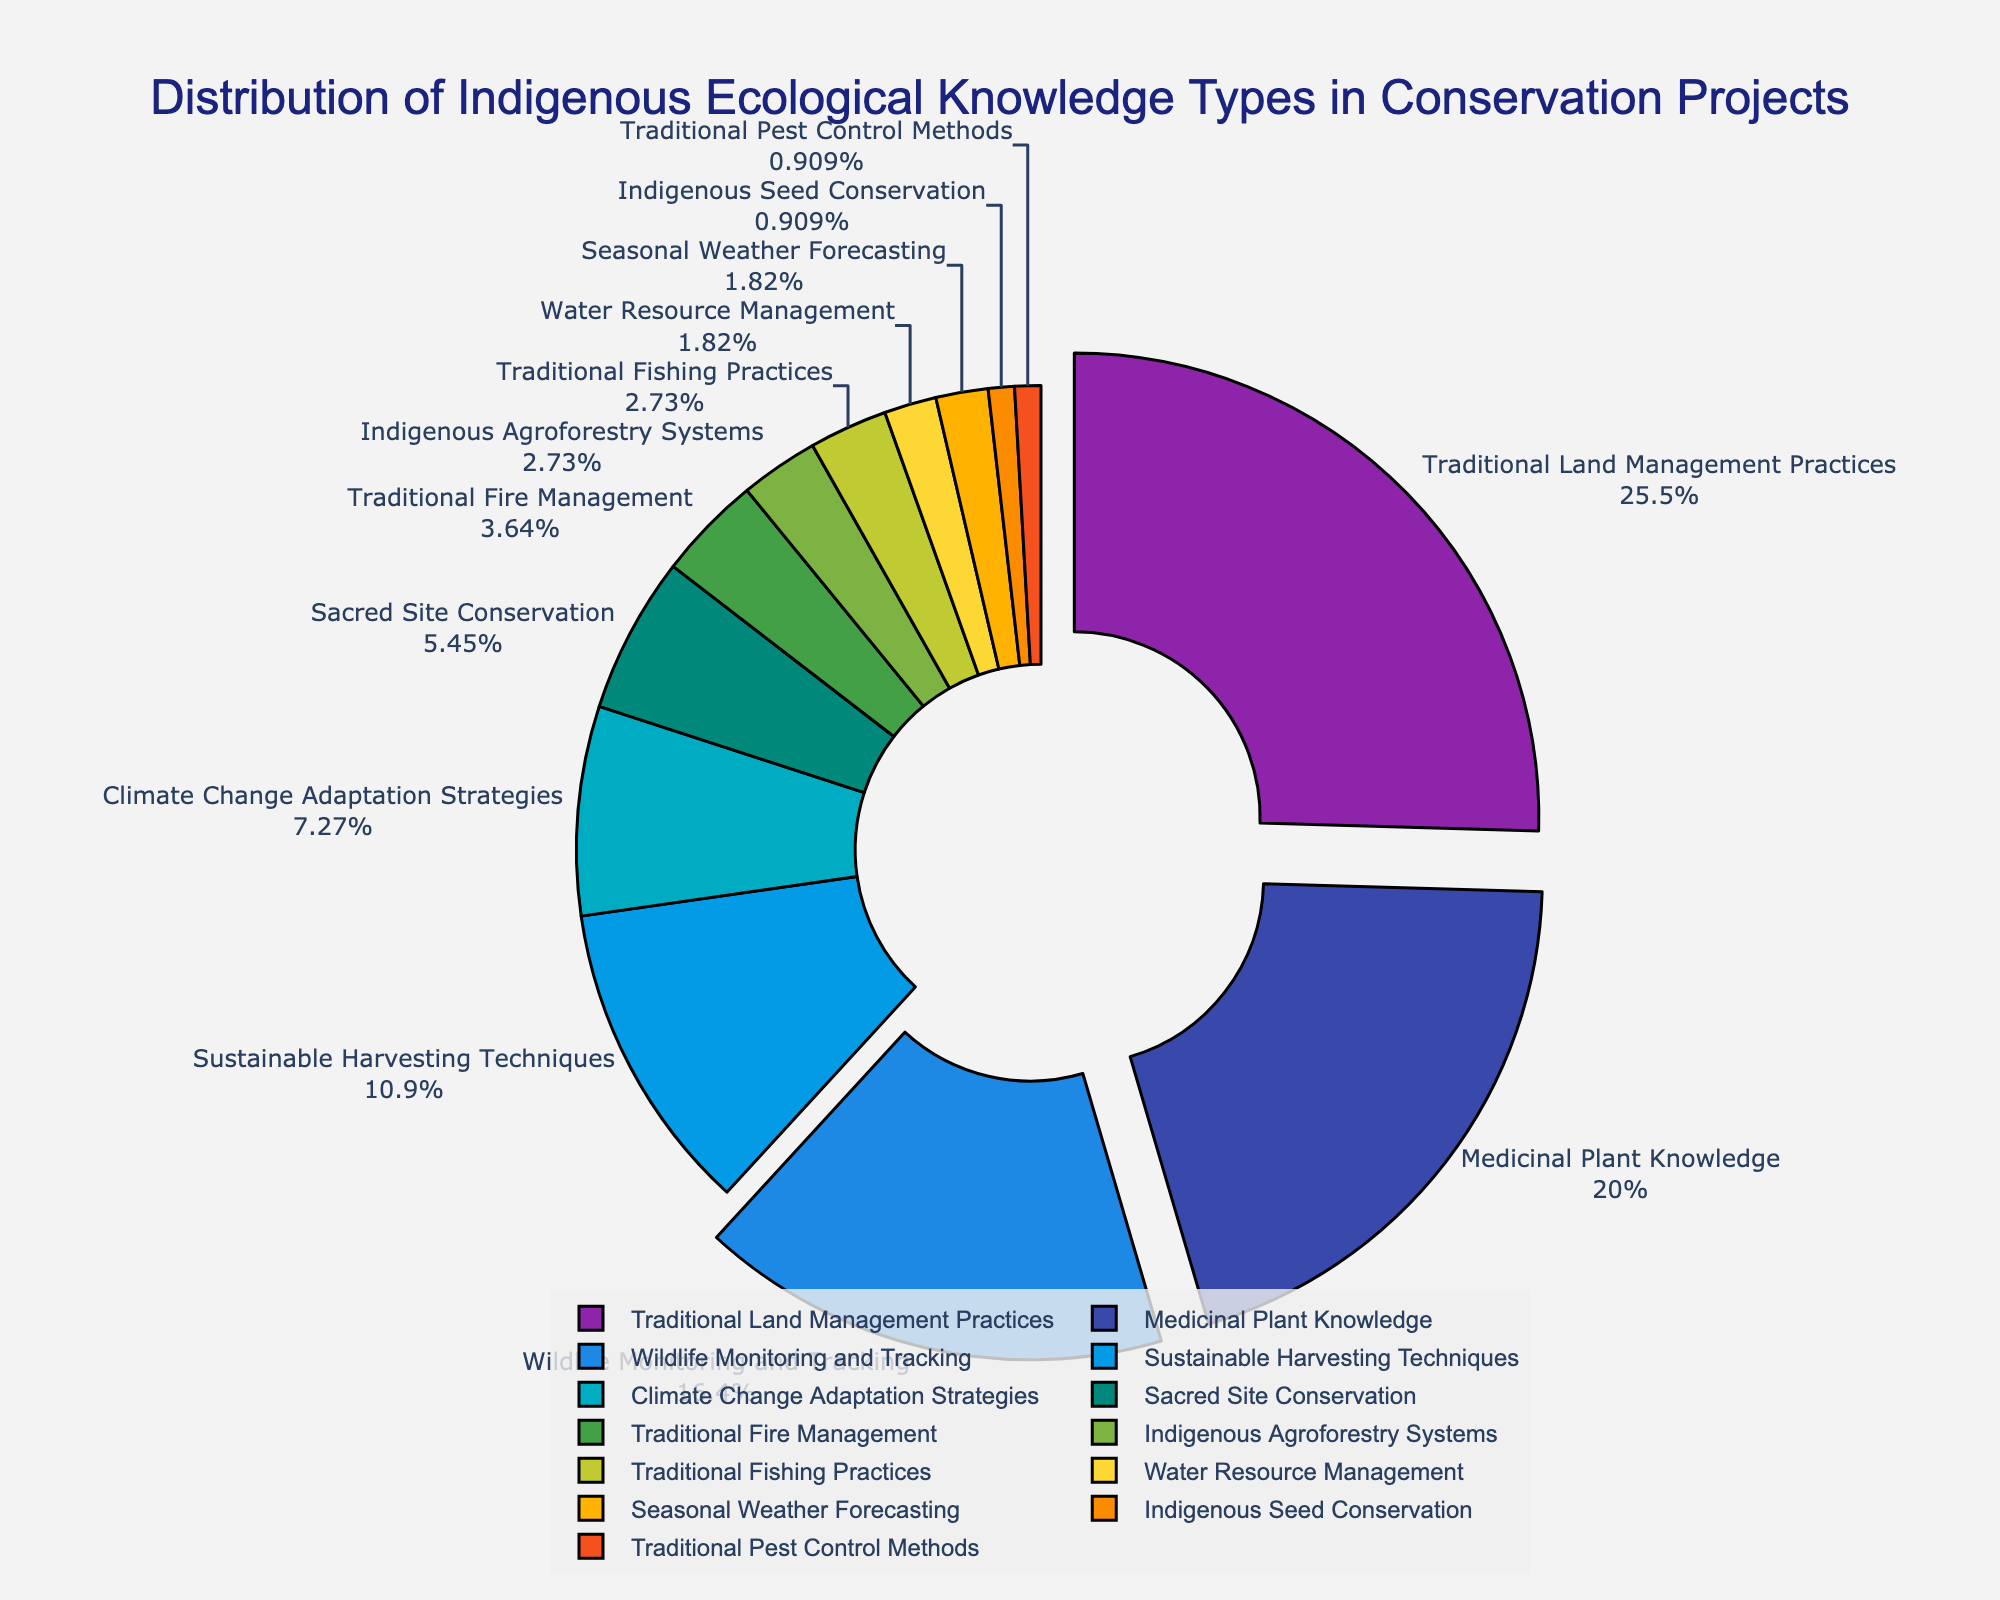What's the most common type of indigenous ecological knowledge incorporated in conservation projects? The largest segment of the pie chart represents Traditional Land Management Practices, making it the most common type.
Answer: Traditional Land Management Practices What is the combined percentage for Medicinal Plant Knowledge and Wildlife Monitoring and Tracking? Medicinal Plant Knowledge is 22% and Wildlife Monitoring and Tracking is 18%. The combined percentage is 22% + 18% = 40%.
Answer: 40% Which indigenous ecological knowledge types make up less than 5% of the total? By looking at each segment, Traditional Fire Management (4%), Indigenous Agroforestry Systems (3%), Traditional Fishing Practices (3%), Water Resource Management (2%), Seasonal Weather Forecasting (2%), Indigenous Seed Conservation (1%), and Traditional Pest Control Methods (1%) all have segments less than 5%.
Answer: Traditional Fire Management, Indigenous Agroforestry Systems, Traditional Fishing Practices, Water Resource Management, Seasonal Weather Forecasting, Indigenous Seed Conservation, Traditional Pest Control Methods How does the percentage of Sustainable Harvesting Techniques compare to Climate Change Adaptation Strategies? Sustainable Harvesting Techniques constitute 12% while Climate Change Adaptation Strategies constitute 8%. Therefore, Sustainable Harvesting Techniques are more common at 12% than Climate Change Adaptation Strategies at 8%.
Answer: Sustainable Harvesting Techniques are more common What is the total percentage of the three least common types of indigenous ecological knowledge? The three least common types are Indigenous Seed Conservation (1%), Traditional Pest Control Methods (1%), and Water Resource Management (2%). Their total percentage is 1% + 1% + 2% = 4%.
Answer: 4% How much larger is the segment for Traditional Land Management Practices compared to Traditional Fire Management? Traditional Land Management Practices are at 28%, and Traditional Fire Management is at 4%. The difference is 28% - 4% = 24%.
Answer: 24% Which two categories together make up just over one quarter of the total? Traditional Land Management Practices (28%) alone already makes up more than one quarter. Therefore, no two categories combined are needed for this value.
Answer: None What is the total percentage for the top three knowledge types? The top three knowledge types are Traditional Land Management Practices (28%), Medicinal Plant Knowledge (22%), and Wildlife Monitoring and Tracking (18%). Their total is 28% + 22% + 18% = 68%.
Answer: 68% Which knowledge type has the smallest representation in conservation projects? The smallest segment in the pie chart represents Traditional Pest Control Methods and Indigenous Seed Conservation, each with 1%.
Answer: Traditional Pest Control Methods, Indigenous Seed Conservation What is the difference in percentage points between Sacred Site Conservation and Traditional Fishing Practices? Sacred Site Conservation is 6% while Traditional Fishing Practices is 3%. The difference is 6% - 3% = 3%.
Answer: 3% 